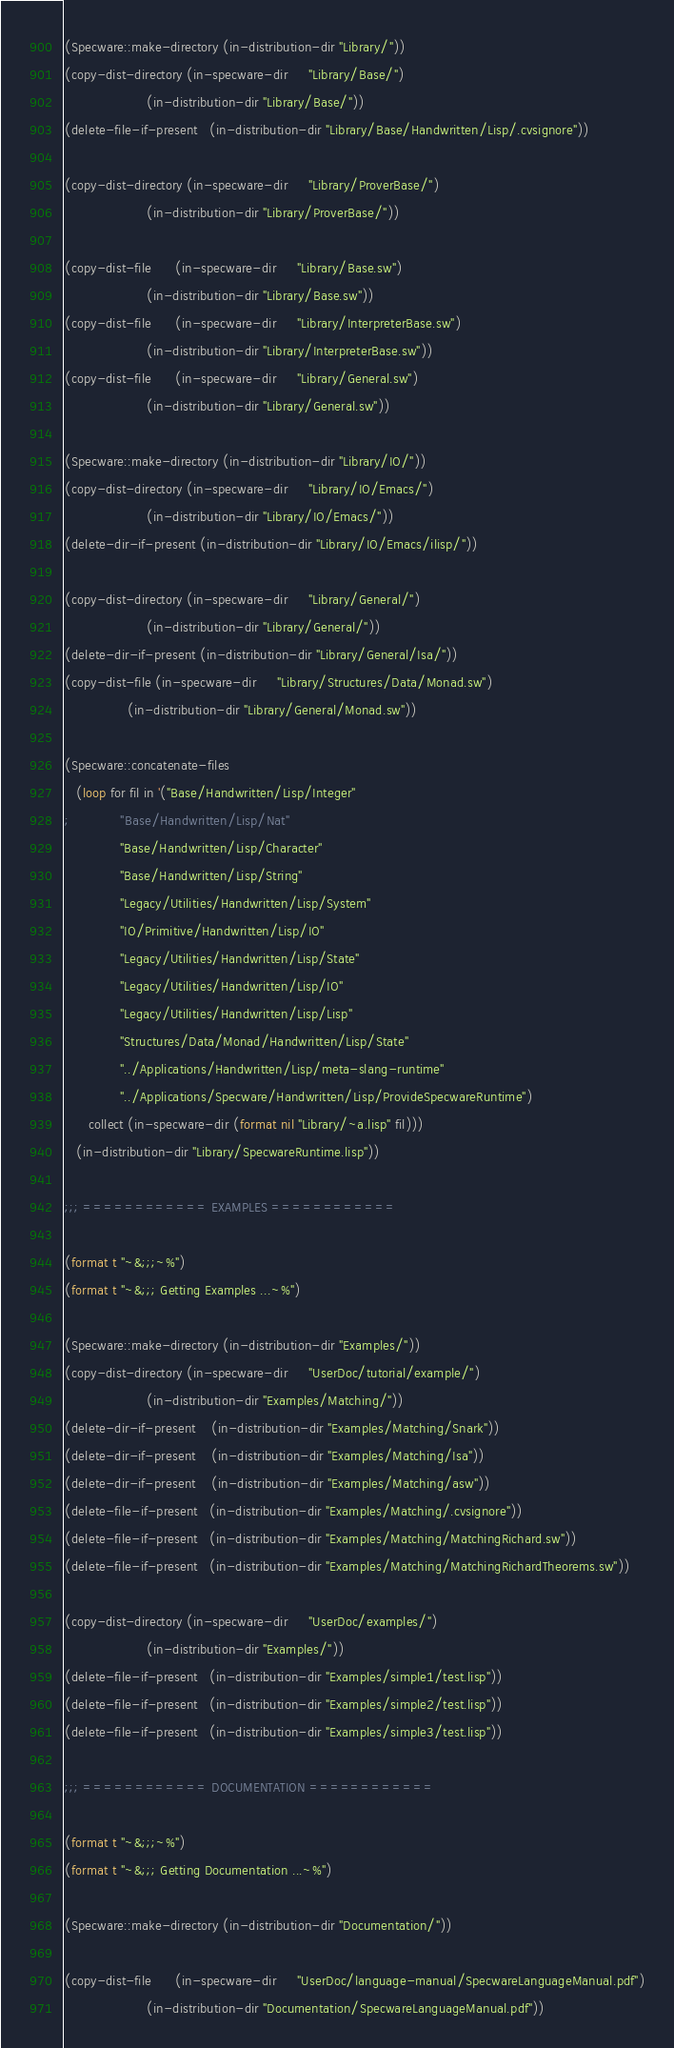Convert code to text. <code><loc_0><loc_0><loc_500><loc_500><_Lisp_>(Specware::make-directory (in-distribution-dir "Library/"))
(copy-dist-directory (in-specware-dir     "Library/Base/")
                     (in-distribution-dir "Library/Base/"))
(delete-file-if-present   (in-distribution-dir "Library/Base/Handwritten/Lisp/.cvsignore"))

(copy-dist-directory (in-specware-dir     "Library/ProverBase/")
                     (in-distribution-dir "Library/ProverBase/"))

(copy-dist-file      (in-specware-dir     "Library/Base.sw")
                     (in-distribution-dir "Library/Base.sw"))
(copy-dist-file      (in-specware-dir     "Library/InterpreterBase.sw")
                     (in-distribution-dir "Library/InterpreterBase.sw"))
(copy-dist-file      (in-specware-dir     "Library/General.sw")
                     (in-distribution-dir "Library/General.sw"))

(Specware::make-directory (in-distribution-dir "Library/IO/"))
(copy-dist-directory (in-specware-dir     "Library/IO/Emacs/")
                     (in-distribution-dir "Library/IO/Emacs/"))
(delete-dir-if-present (in-distribution-dir "Library/IO/Emacs/ilisp/"))

(copy-dist-directory (in-specware-dir     "Library/General/")
                     (in-distribution-dir "Library/General/"))
(delete-dir-if-present (in-distribution-dir "Library/General/Isa/"))
(copy-dist-file (in-specware-dir     "Library/Structures/Data/Monad.sw")
                (in-distribution-dir "Library/General/Monad.sw"))

(Specware::concatenate-files
   (loop for fil in '("Base/Handwritten/Lisp/Integer"
; 		      "Base/Handwritten/Lisp/Nat"
		      "Base/Handwritten/Lisp/Character"
		      "Base/Handwritten/Lisp/String"
		      "Legacy/Utilities/Handwritten/Lisp/System"
		      "IO/Primitive/Handwritten/Lisp/IO"
		      "Legacy/Utilities/Handwritten/Lisp/State"
		      "Legacy/Utilities/Handwritten/Lisp/IO"
		      "Legacy/Utilities/Handwritten/Lisp/Lisp"
		      "Structures/Data/Monad/Handwritten/Lisp/State"
		      "../Applications/Handwritten/Lisp/meta-slang-runtime"
		      "../Applications/Specware/Handwritten/Lisp/ProvideSpecwareRuntime")
      collect (in-specware-dir (format nil "Library/~a.lisp" fil)))
   (in-distribution-dir "Library/SpecwareRuntime.lisp"))

;;; ============ EXAMPLES ============

(format t "~&;;;~%")
(format t "~&;;; Getting Examples ...~%")

(Specware::make-directory (in-distribution-dir "Examples/"))
(copy-dist-directory (in-specware-dir     "UserDoc/tutorial/example/")
                     (in-distribution-dir "Examples/Matching/"))
(delete-dir-if-present    (in-distribution-dir "Examples/Matching/Snark"))
(delete-dir-if-present    (in-distribution-dir "Examples/Matching/Isa"))
(delete-dir-if-present    (in-distribution-dir "Examples/Matching/asw"))
(delete-file-if-present   (in-distribution-dir "Examples/Matching/.cvsignore"))
(delete-file-if-present   (in-distribution-dir "Examples/Matching/MatchingRichard.sw"))
(delete-file-if-present   (in-distribution-dir "Examples/Matching/MatchingRichardTheorems.sw"))

(copy-dist-directory (in-specware-dir     "UserDoc/examples/")
                     (in-distribution-dir "Examples/"))
(delete-file-if-present   (in-distribution-dir "Examples/simple1/test.lisp"))
(delete-file-if-present   (in-distribution-dir "Examples/simple2/test.lisp"))
(delete-file-if-present   (in-distribution-dir "Examples/simple3/test.lisp"))

;;; ============ DOCUMENTATION ============

(format t "~&;;;~%")
(format t "~&;;; Getting Documentation ...~%")

(Specware::make-directory (in-distribution-dir "Documentation/"))

(copy-dist-file      (in-specware-dir     "UserDoc/language-manual/SpecwareLanguageManual.pdf")
                     (in-distribution-dir "Documentation/SpecwareLanguageManual.pdf"))</code> 